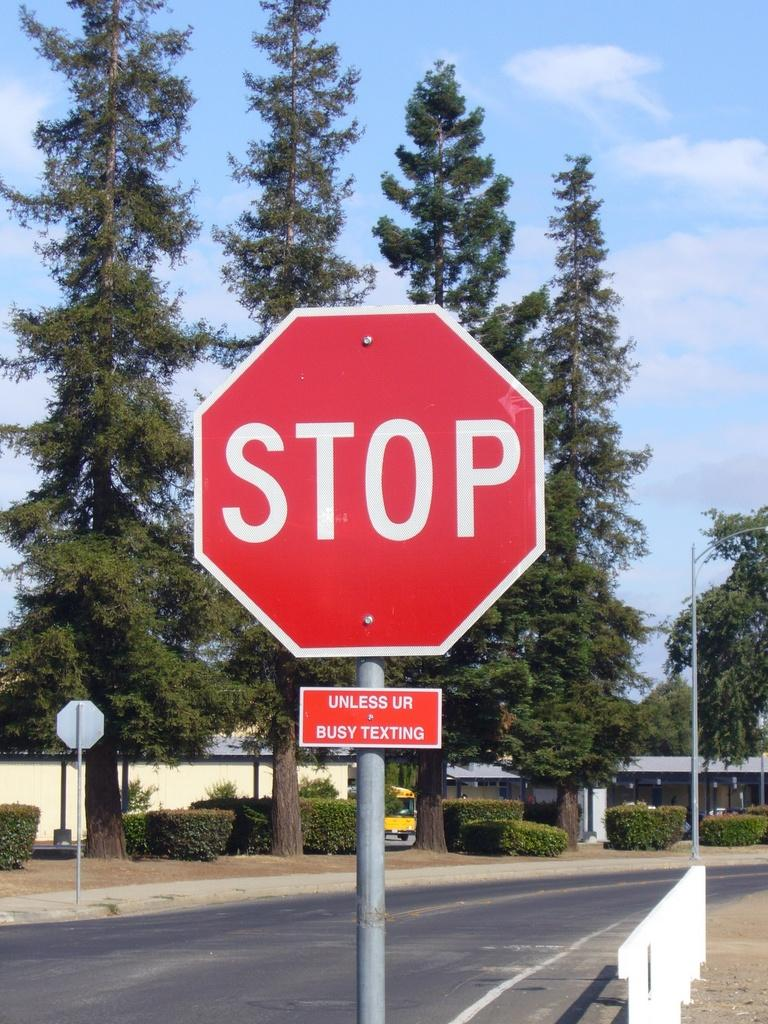<image>
Create a compact narrative representing the image presented. A red and white sign that reads STOP in white letters. 